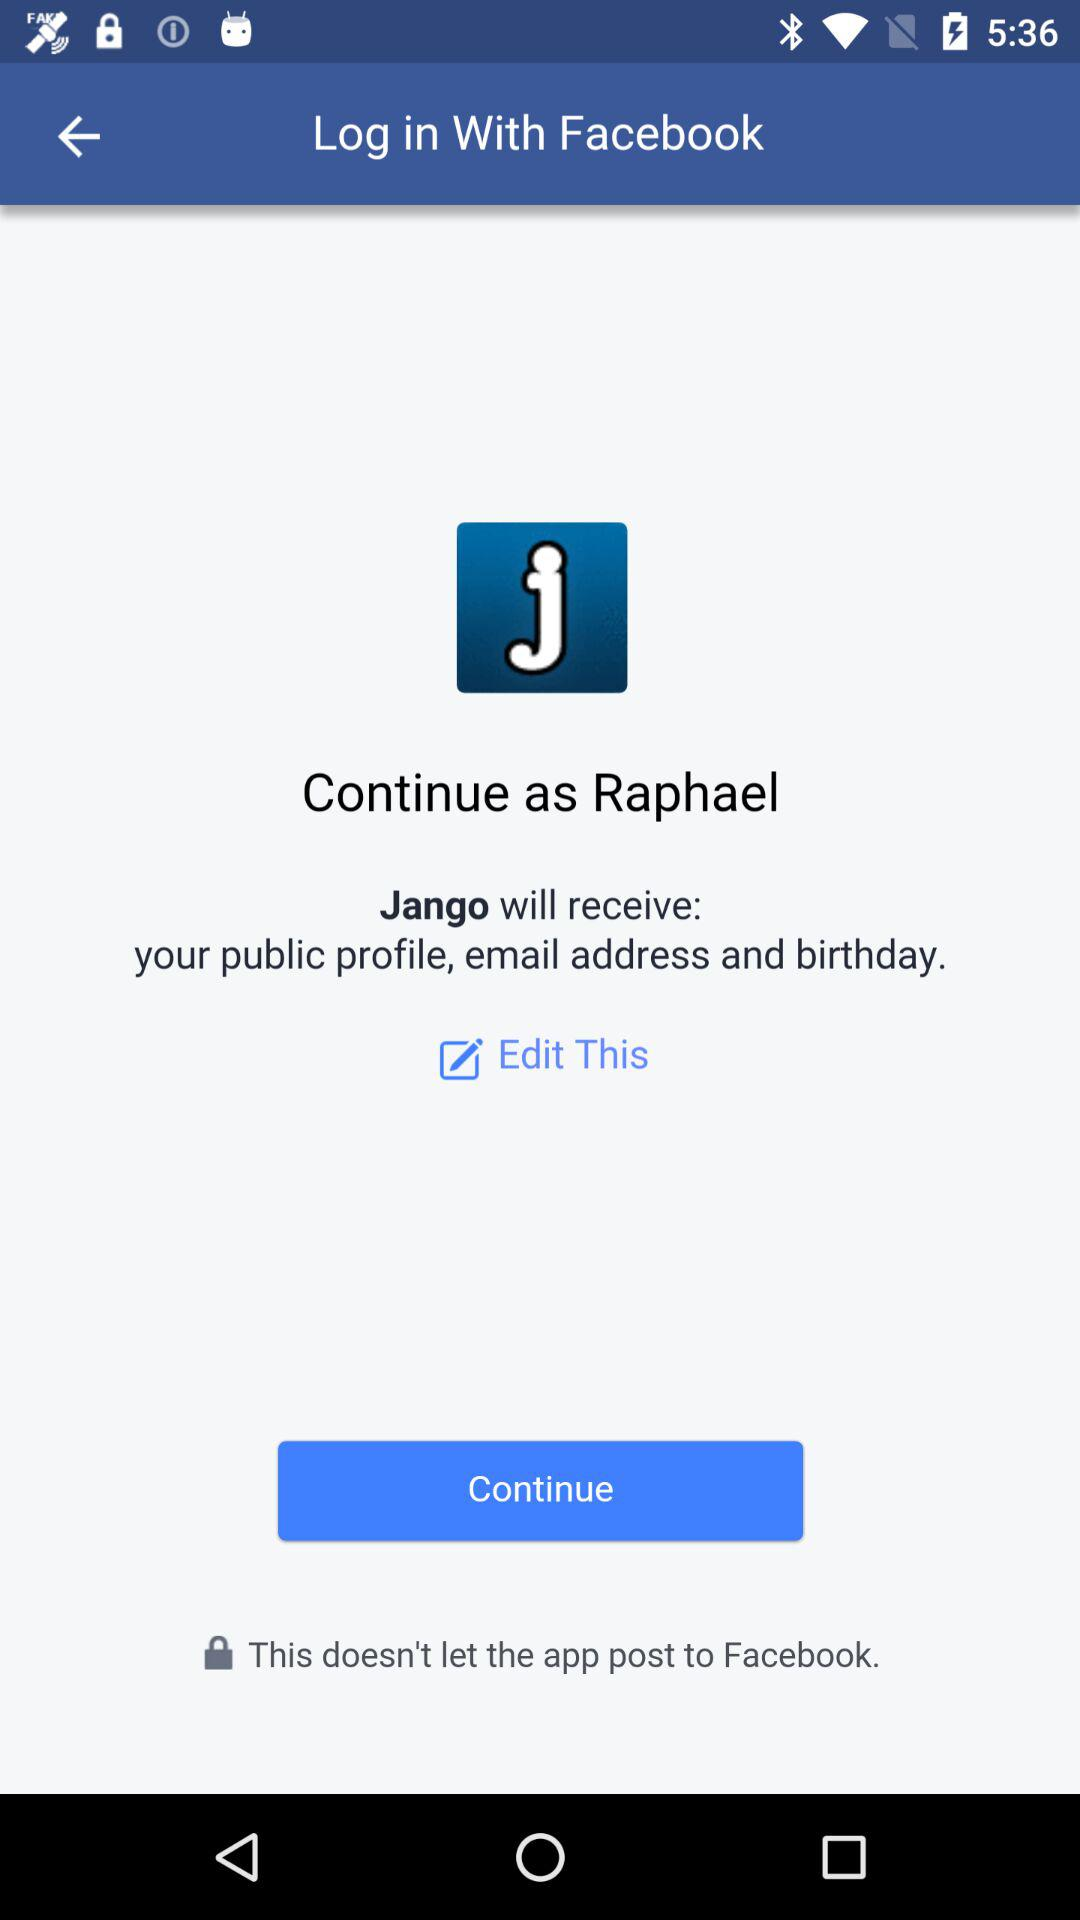What is the login name? The login name is Raphael. 